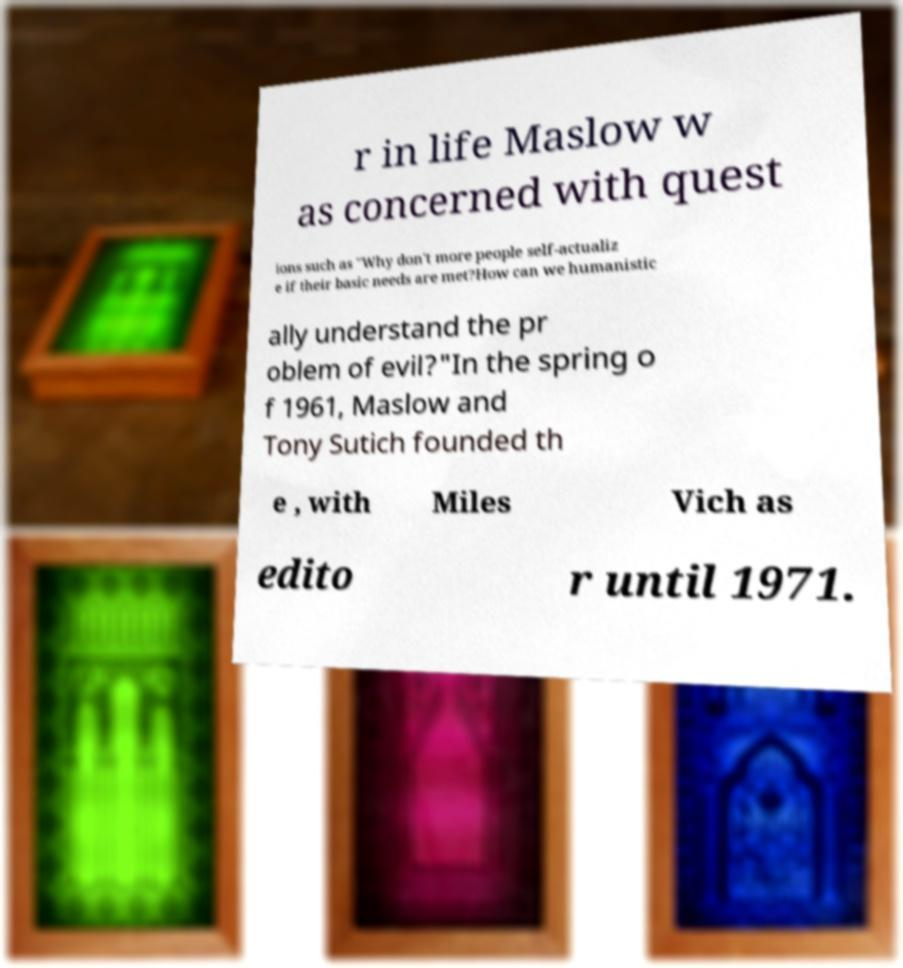There's text embedded in this image that I need extracted. Can you transcribe it verbatim? r in life Maslow w as concerned with quest ions such as "Why don't more people self-actualiz e if their basic needs are met?How can we humanistic ally understand the pr oblem of evil?"In the spring o f 1961, Maslow and Tony Sutich founded th e , with Miles Vich as edito r until 1971. 